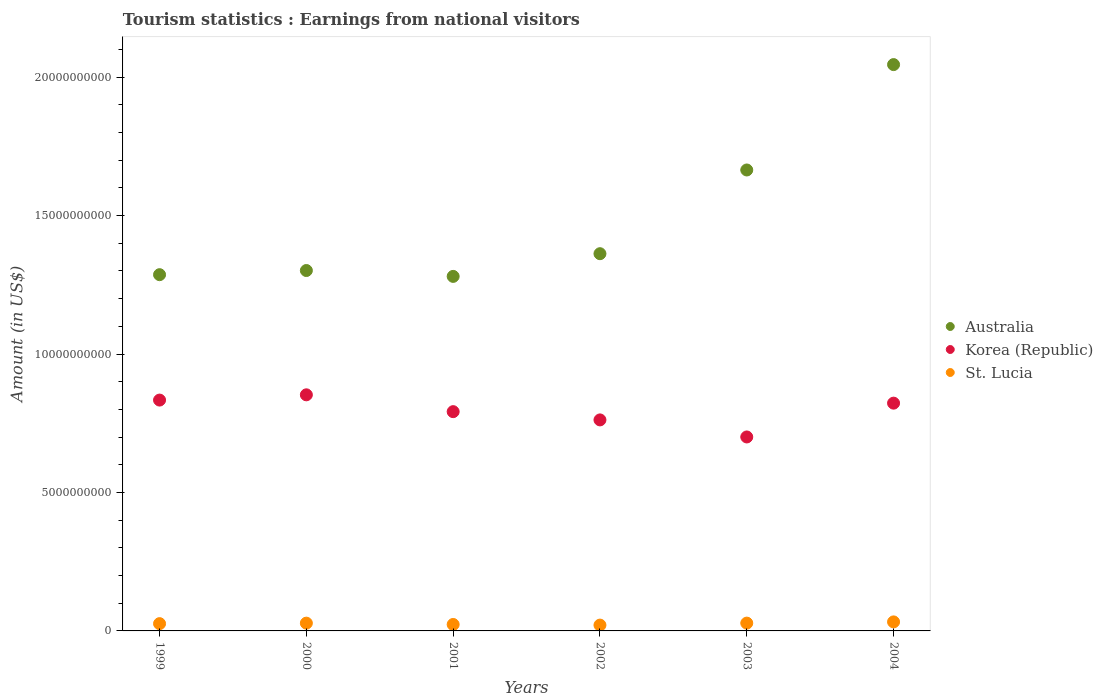How many different coloured dotlines are there?
Ensure brevity in your answer.  3. What is the earnings from national visitors in St. Lucia in 2004?
Your answer should be compact. 3.26e+08. Across all years, what is the maximum earnings from national visitors in Korea (Republic)?
Provide a short and direct response. 8.53e+09. Across all years, what is the minimum earnings from national visitors in St. Lucia?
Ensure brevity in your answer.  2.10e+08. In which year was the earnings from national visitors in Australia maximum?
Your answer should be compact. 2004. In which year was the earnings from national visitors in Korea (Republic) minimum?
Keep it short and to the point. 2003. What is the total earnings from national visitors in Australia in the graph?
Offer a very short reply. 8.94e+1. What is the difference between the earnings from national visitors in St. Lucia in 1999 and that in 2001?
Your answer should be very brief. 3.00e+07. What is the difference between the earnings from national visitors in St. Lucia in 2003 and the earnings from national visitors in Australia in 2000?
Provide a short and direct response. -1.27e+1. What is the average earnings from national visitors in St. Lucia per year?
Keep it short and to the point. 2.66e+08. In the year 2002, what is the difference between the earnings from national visitors in St. Lucia and earnings from national visitors in Korea (Republic)?
Make the answer very short. -7.41e+09. In how many years, is the earnings from national visitors in Korea (Republic) greater than 3000000000 US$?
Your answer should be very brief. 6. What is the ratio of the earnings from national visitors in St. Lucia in 2000 to that in 2003?
Ensure brevity in your answer.  1. Is the earnings from national visitors in St. Lucia in 2000 less than that in 2002?
Keep it short and to the point. No. Is the difference between the earnings from national visitors in St. Lucia in 1999 and 2004 greater than the difference between the earnings from national visitors in Korea (Republic) in 1999 and 2004?
Offer a very short reply. No. What is the difference between the highest and the second highest earnings from national visitors in Australia?
Offer a terse response. 3.81e+09. What is the difference between the highest and the lowest earnings from national visitors in Korea (Republic)?
Your answer should be very brief. 1.52e+09. Is the sum of the earnings from national visitors in Australia in 1999 and 2003 greater than the maximum earnings from national visitors in St. Lucia across all years?
Provide a succinct answer. Yes. Is the earnings from national visitors in Korea (Republic) strictly greater than the earnings from national visitors in Australia over the years?
Keep it short and to the point. No. How many dotlines are there?
Give a very brief answer. 3. How many years are there in the graph?
Your answer should be very brief. 6. Does the graph contain any zero values?
Provide a succinct answer. No. Does the graph contain grids?
Your response must be concise. No. How many legend labels are there?
Ensure brevity in your answer.  3. How are the legend labels stacked?
Provide a short and direct response. Vertical. What is the title of the graph?
Provide a short and direct response. Tourism statistics : Earnings from national visitors. Does "Sub-Saharan Africa (developing only)" appear as one of the legend labels in the graph?
Your response must be concise. No. What is the label or title of the Y-axis?
Keep it short and to the point. Amount (in US$). What is the Amount (in US$) of Australia in 1999?
Provide a short and direct response. 1.29e+1. What is the Amount (in US$) of Korea (Republic) in 1999?
Keep it short and to the point. 8.34e+09. What is the Amount (in US$) in St. Lucia in 1999?
Ensure brevity in your answer.  2.63e+08. What is the Amount (in US$) of Australia in 2000?
Your response must be concise. 1.30e+1. What is the Amount (in US$) in Korea (Republic) in 2000?
Give a very brief answer. 8.53e+09. What is the Amount (in US$) in St. Lucia in 2000?
Offer a very short reply. 2.81e+08. What is the Amount (in US$) in Australia in 2001?
Your answer should be compact. 1.28e+1. What is the Amount (in US$) of Korea (Republic) in 2001?
Offer a terse response. 7.92e+09. What is the Amount (in US$) in St. Lucia in 2001?
Keep it short and to the point. 2.33e+08. What is the Amount (in US$) in Australia in 2002?
Your answer should be very brief. 1.36e+1. What is the Amount (in US$) in Korea (Republic) in 2002?
Offer a very short reply. 7.62e+09. What is the Amount (in US$) in St. Lucia in 2002?
Keep it short and to the point. 2.10e+08. What is the Amount (in US$) in Australia in 2003?
Give a very brief answer. 1.66e+1. What is the Amount (in US$) of Korea (Republic) in 2003?
Give a very brief answer. 7.00e+09. What is the Amount (in US$) of St. Lucia in 2003?
Offer a terse response. 2.82e+08. What is the Amount (in US$) in Australia in 2004?
Keep it short and to the point. 2.05e+1. What is the Amount (in US$) in Korea (Republic) in 2004?
Provide a succinct answer. 8.23e+09. What is the Amount (in US$) of St. Lucia in 2004?
Offer a very short reply. 3.26e+08. Across all years, what is the maximum Amount (in US$) in Australia?
Ensure brevity in your answer.  2.05e+1. Across all years, what is the maximum Amount (in US$) in Korea (Republic)?
Give a very brief answer. 8.53e+09. Across all years, what is the maximum Amount (in US$) of St. Lucia?
Make the answer very short. 3.26e+08. Across all years, what is the minimum Amount (in US$) of Australia?
Offer a very short reply. 1.28e+1. Across all years, what is the minimum Amount (in US$) of Korea (Republic)?
Your answer should be very brief. 7.00e+09. Across all years, what is the minimum Amount (in US$) of St. Lucia?
Your answer should be compact. 2.10e+08. What is the total Amount (in US$) in Australia in the graph?
Provide a short and direct response. 8.94e+1. What is the total Amount (in US$) in Korea (Republic) in the graph?
Ensure brevity in your answer.  4.76e+1. What is the total Amount (in US$) in St. Lucia in the graph?
Provide a short and direct response. 1.60e+09. What is the difference between the Amount (in US$) in Australia in 1999 and that in 2000?
Keep it short and to the point. -1.50e+08. What is the difference between the Amount (in US$) of Korea (Republic) in 1999 and that in 2000?
Provide a succinct answer. -1.90e+08. What is the difference between the Amount (in US$) in St. Lucia in 1999 and that in 2000?
Offer a very short reply. -1.80e+07. What is the difference between the Amount (in US$) in Australia in 1999 and that in 2001?
Make the answer very short. 6.20e+07. What is the difference between the Amount (in US$) in Korea (Republic) in 1999 and that in 2001?
Give a very brief answer. 4.18e+08. What is the difference between the Amount (in US$) of St. Lucia in 1999 and that in 2001?
Your answer should be compact. 3.00e+07. What is the difference between the Amount (in US$) in Australia in 1999 and that in 2002?
Keep it short and to the point. -7.58e+08. What is the difference between the Amount (in US$) of Korea (Republic) in 1999 and that in 2002?
Provide a succinct answer. 7.16e+08. What is the difference between the Amount (in US$) of St. Lucia in 1999 and that in 2002?
Keep it short and to the point. 5.30e+07. What is the difference between the Amount (in US$) of Australia in 1999 and that in 2003?
Keep it short and to the point. -3.78e+09. What is the difference between the Amount (in US$) of Korea (Republic) in 1999 and that in 2003?
Keep it short and to the point. 1.33e+09. What is the difference between the Amount (in US$) of St. Lucia in 1999 and that in 2003?
Keep it short and to the point. -1.90e+07. What is the difference between the Amount (in US$) of Australia in 1999 and that in 2004?
Offer a terse response. -7.59e+09. What is the difference between the Amount (in US$) of Korea (Republic) in 1999 and that in 2004?
Your response must be concise. 1.11e+08. What is the difference between the Amount (in US$) of St. Lucia in 1999 and that in 2004?
Keep it short and to the point. -6.30e+07. What is the difference between the Amount (in US$) in Australia in 2000 and that in 2001?
Keep it short and to the point. 2.12e+08. What is the difference between the Amount (in US$) of Korea (Republic) in 2000 and that in 2001?
Ensure brevity in your answer.  6.08e+08. What is the difference between the Amount (in US$) of St. Lucia in 2000 and that in 2001?
Provide a succinct answer. 4.80e+07. What is the difference between the Amount (in US$) of Australia in 2000 and that in 2002?
Provide a short and direct response. -6.08e+08. What is the difference between the Amount (in US$) of Korea (Republic) in 2000 and that in 2002?
Your answer should be very brief. 9.06e+08. What is the difference between the Amount (in US$) in St. Lucia in 2000 and that in 2002?
Your response must be concise. 7.10e+07. What is the difference between the Amount (in US$) of Australia in 2000 and that in 2003?
Provide a short and direct response. -3.63e+09. What is the difference between the Amount (in US$) in Korea (Republic) in 2000 and that in 2003?
Provide a short and direct response. 1.52e+09. What is the difference between the Amount (in US$) of St. Lucia in 2000 and that in 2003?
Keep it short and to the point. -1.00e+06. What is the difference between the Amount (in US$) in Australia in 2000 and that in 2004?
Offer a terse response. -7.44e+09. What is the difference between the Amount (in US$) in Korea (Republic) in 2000 and that in 2004?
Offer a very short reply. 3.01e+08. What is the difference between the Amount (in US$) of St. Lucia in 2000 and that in 2004?
Keep it short and to the point. -4.50e+07. What is the difference between the Amount (in US$) of Australia in 2001 and that in 2002?
Offer a terse response. -8.20e+08. What is the difference between the Amount (in US$) of Korea (Republic) in 2001 and that in 2002?
Your answer should be very brief. 2.98e+08. What is the difference between the Amount (in US$) of St. Lucia in 2001 and that in 2002?
Ensure brevity in your answer.  2.30e+07. What is the difference between the Amount (in US$) of Australia in 2001 and that in 2003?
Give a very brief answer. -3.84e+09. What is the difference between the Amount (in US$) in Korea (Republic) in 2001 and that in 2003?
Ensure brevity in your answer.  9.14e+08. What is the difference between the Amount (in US$) of St. Lucia in 2001 and that in 2003?
Offer a very short reply. -4.90e+07. What is the difference between the Amount (in US$) in Australia in 2001 and that in 2004?
Offer a very short reply. -7.65e+09. What is the difference between the Amount (in US$) of Korea (Republic) in 2001 and that in 2004?
Your answer should be very brief. -3.07e+08. What is the difference between the Amount (in US$) of St. Lucia in 2001 and that in 2004?
Offer a terse response. -9.30e+07. What is the difference between the Amount (in US$) in Australia in 2002 and that in 2003?
Your answer should be very brief. -3.02e+09. What is the difference between the Amount (in US$) in Korea (Republic) in 2002 and that in 2003?
Offer a terse response. 6.16e+08. What is the difference between the Amount (in US$) of St. Lucia in 2002 and that in 2003?
Your answer should be compact. -7.20e+07. What is the difference between the Amount (in US$) of Australia in 2002 and that in 2004?
Your response must be concise. -6.83e+09. What is the difference between the Amount (in US$) in Korea (Republic) in 2002 and that in 2004?
Ensure brevity in your answer.  -6.05e+08. What is the difference between the Amount (in US$) of St. Lucia in 2002 and that in 2004?
Your answer should be compact. -1.16e+08. What is the difference between the Amount (in US$) of Australia in 2003 and that in 2004?
Keep it short and to the point. -3.81e+09. What is the difference between the Amount (in US$) in Korea (Republic) in 2003 and that in 2004?
Your answer should be very brief. -1.22e+09. What is the difference between the Amount (in US$) in St. Lucia in 2003 and that in 2004?
Offer a very short reply. -4.40e+07. What is the difference between the Amount (in US$) in Australia in 1999 and the Amount (in US$) in Korea (Republic) in 2000?
Offer a very short reply. 4.34e+09. What is the difference between the Amount (in US$) in Australia in 1999 and the Amount (in US$) in St. Lucia in 2000?
Your answer should be compact. 1.26e+1. What is the difference between the Amount (in US$) in Korea (Republic) in 1999 and the Amount (in US$) in St. Lucia in 2000?
Your answer should be compact. 8.06e+09. What is the difference between the Amount (in US$) in Australia in 1999 and the Amount (in US$) in Korea (Republic) in 2001?
Offer a very short reply. 4.95e+09. What is the difference between the Amount (in US$) in Australia in 1999 and the Amount (in US$) in St. Lucia in 2001?
Provide a short and direct response. 1.26e+1. What is the difference between the Amount (in US$) in Korea (Republic) in 1999 and the Amount (in US$) in St. Lucia in 2001?
Provide a succinct answer. 8.10e+09. What is the difference between the Amount (in US$) in Australia in 1999 and the Amount (in US$) in Korea (Republic) in 2002?
Offer a very short reply. 5.24e+09. What is the difference between the Amount (in US$) of Australia in 1999 and the Amount (in US$) of St. Lucia in 2002?
Ensure brevity in your answer.  1.27e+1. What is the difference between the Amount (in US$) of Korea (Republic) in 1999 and the Amount (in US$) of St. Lucia in 2002?
Provide a succinct answer. 8.13e+09. What is the difference between the Amount (in US$) in Australia in 1999 and the Amount (in US$) in Korea (Republic) in 2003?
Make the answer very short. 5.86e+09. What is the difference between the Amount (in US$) of Australia in 1999 and the Amount (in US$) of St. Lucia in 2003?
Your answer should be compact. 1.26e+1. What is the difference between the Amount (in US$) of Korea (Republic) in 1999 and the Amount (in US$) of St. Lucia in 2003?
Your response must be concise. 8.06e+09. What is the difference between the Amount (in US$) in Australia in 1999 and the Amount (in US$) in Korea (Republic) in 2004?
Offer a very short reply. 4.64e+09. What is the difference between the Amount (in US$) in Australia in 1999 and the Amount (in US$) in St. Lucia in 2004?
Provide a succinct answer. 1.25e+1. What is the difference between the Amount (in US$) in Korea (Republic) in 1999 and the Amount (in US$) in St. Lucia in 2004?
Provide a succinct answer. 8.01e+09. What is the difference between the Amount (in US$) in Australia in 2000 and the Amount (in US$) in Korea (Republic) in 2001?
Your response must be concise. 5.10e+09. What is the difference between the Amount (in US$) in Australia in 2000 and the Amount (in US$) in St. Lucia in 2001?
Give a very brief answer. 1.28e+1. What is the difference between the Amount (in US$) in Korea (Republic) in 2000 and the Amount (in US$) in St. Lucia in 2001?
Your answer should be compact. 8.29e+09. What is the difference between the Amount (in US$) of Australia in 2000 and the Amount (in US$) of Korea (Republic) in 2002?
Offer a very short reply. 5.40e+09. What is the difference between the Amount (in US$) of Australia in 2000 and the Amount (in US$) of St. Lucia in 2002?
Provide a short and direct response. 1.28e+1. What is the difference between the Amount (in US$) of Korea (Republic) in 2000 and the Amount (in US$) of St. Lucia in 2002?
Keep it short and to the point. 8.32e+09. What is the difference between the Amount (in US$) of Australia in 2000 and the Amount (in US$) of Korea (Republic) in 2003?
Keep it short and to the point. 6.01e+09. What is the difference between the Amount (in US$) in Australia in 2000 and the Amount (in US$) in St. Lucia in 2003?
Your answer should be compact. 1.27e+1. What is the difference between the Amount (in US$) in Korea (Republic) in 2000 and the Amount (in US$) in St. Lucia in 2003?
Offer a very short reply. 8.24e+09. What is the difference between the Amount (in US$) of Australia in 2000 and the Amount (in US$) of Korea (Republic) in 2004?
Ensure brevity in your answer.  4.79e+09. What is the difference between the Amount (in US$) of Australia in 2000 and the Amount (in US$) of St. Lucia in 2004?
Your answer should be very brief. 1.27e+1. What is the difference between the Amount (in US$) of Korea (Republic) in 2000 and the Amount (in US$) of St. Lucia in 2004?
Provide a succinct answer. 8.20e+09. What is the difference between the Amount (in US$) in Australia in 2001 and the Amount (in US$) in Korea (Republic) in 2002?
Make the answer very short. 5.18e+09. What is the difference between the Amount (in US$) of Australia in 2001 and the Amount (in US$) of St. Lucia in 2002?
Provide a succinct answer. 1.26e+1. What is the difference between the Amount (in US$) in Korea (Republic) in 2001 and the Amount (in US$) in St. Lucia in 2002?
Offer a terse response. 7.71e+09. What is the difference between the Amount (in US$) in Australia in 2001 and the Amount (in US$) in Korea (Republic) in 2003?
Offer a terse response. 5.80e+09. What is the difference between the Amount (in US$) of Australia in 2001 and the Amount (in US$) of St. Lucia in 2003?
Make the answer very short. 1.25e+1. What is the difference between the Amount (in US$) of Korea (Republic) in 2001 and the Amount (in US$) of St. Lucia in 2003?
Offer a terse response. 7.64e+09. What is the difference between the Amount (in US$) in Australia in 2001 and the Amount (in US$) in Korea (Republic) in 2004?
Your answer should be very brief. 4.58e+09. What is the difference between the Amount (in US$) of Australia in 2001 and the Amount (in US$) of St. Lucia in 2004?
Your answer should be very brief. 1.25e+1. What is the difference between the Amount (in US$) in Korea (Republic) in 2001 and the Amount (in US$) in St. Lucia in 2004?
Provide a short and direct response. 7.59e+09. What is the difference between the Amount (in US$) in Australia in 2002 and the Amount (in US$) in Korea (Republic) in 2003?
Make the answer very short. 6.62e+09. What is the difference between the Amount (in US$) of Australia in 2002 and the Amount (in US$) of St. Lucia in 2003?
Keep it short and to the point. 1.33e+1. What is the difference between the Amount (in US$) of Korea (Republic) in 2002 and the Amount (in US$) of St. Lucia in 2003?
Ensure brevity in your answer.  7.34e+09. What is the difference between the Amount (in US$) of Australia in 2002 and the Amount (in US$) of Korea (Republic) in 2004?
Offer a very short reply. 5.40e+09. What is the difference between the Amount (in US$) of Australia in 2002 and the Amount (in US$) of St. Lucia in 2004?
Offer a terse response. 1.33e+1. What is the difference between the Amount (in US$) of Korea (Republic) in 2002 and the Amount (in US$) of St. Lucia in 2004?
Keep it short and to the point. 7.30e+09. What is the difference between the Amount (in US$) in Australia in 2003 and the Amount (in US$) in Korea (Republic) in 2004?
Your response must be concise. 8.42e+09. What is the difference between the Amount (in US$) in Australia in 2003 and the Amount (in US$) in St. Lucia in 2004?
Your answer should be compact. 1.63e+1. What is the difference between the Amount (in US$) of Korea (Republic) in 2003 and the Amount (in US$) of St. Lucia in 2004?
Offer a terse response. 6.68e+09. What is the average Amount (in US$) of Australia per year?
Provide a succinct answer. 1.49e+1. What is the average Amount (in US$) in Korea (Republic) per year?
Provide a short and direct response. 7.94e+09. What is the average Amount (in US$) in St. Lucia per year?
Your response must be concise. 2.66e+08. In the year 1999, what is the difference between the Amount (in US$) of Australia and Amount (in US$) of Korea (Republic)?
Provide a short and direct response. 4.53e+09. In the year 1999, what is the difference between the Amount (in US$) of Australia and Amount (in US$) of St. Lucia?
Your answer should be very brief. 1.26e+1. In the year 1999, what is the difference between the Amount (in US$) in Korea (Republic) and Amount (in US$) in St. Lucia?
Give a very brief answer. 8.07e+09. In the year 2000, what is the difference between the Amount (in US$) of Australia and Amount (in US$) of Korea (Republic)?
Make the answer very short. 4.49e+09. In the year 2000, what is the difference between the Amount (in US$) of Australia and Amount (in US$) of St. Lucia?
Ensure brevity in your answer.  1.27e+1. In the year 2000, what is the difference between the Amount (in US$) in Korea (Republic) and Amount (in US$) in St. Lucia?
Keep it short and to the point. 8.25e+09. In the year 2001, what is the difference between the Amount (in US$) in Australia and Amount (in US$) in Korea (Republic)?
Make the answer very short. 4.88e+09. In the year 2001, what is the difference between the Amount (in US$) of Australia and Amount (in US$) of St. Lucia?
Your answer should be compact. 1.26e+1. In the year 2001, what is the difference between the Amount (in US$) in Korea (Republic) and Amount (in US$) in St. Lucia?
Keep it short and to the point. 7.69e+09. In the year 2002, what is the difference between the Amount (in US$) of Australia and Amount (in US$) of Korea (Republic)?
Offer a very short reply. 6.00e+09. In the year 2002, what is the difference between the Amount (in US$) in Australia and Amount (in US$) in St. Lucia?
Provide a succinct answer. 1.34e+1. In the year 2002, what is the difference between the Amount (in US$) of Korea (Republic) and Amount (in US$) of St. Lucia?
Offer a very short reply. 7.41e+09. In the year 2003, what is the difference between the Amount (in US$) in Australia and Amount (in US$) in Korea (Republic)?
Give a very brief answer. 9.64e+09. In the year 2003, what is the difference between the Amount (in US$) in Australia and Amount (in US$) in St. Lucia?
Ensure brevity in your answer.  1.64e+1. In the year 2003, what is the difference between the Amount (in US$) of Korea (Republic) and Amount (in US$) of St. Lucia?
Offer a very short reply. 6.72e+09. In the year 2004, what is the difference between the Amount (in US$) of Australia and Amount (in US$) of Korea (Republic)?
Give a very brief answer. 1.22e+1. In the year 2004, what is the difference between the Amount (in US$) of Australia and Amount (in US$) of St. Lucia?
Your answer should be very brief. 2.01e+1. In the year 2004, what is the difference between the Amount (in US$) in Korea (Republic) and Amount (in US$) in St. Lucia?
Provide a succinct answer. 7.90e+09. What is the ratio of the Amount (in US$) of Australia in 1999 to that in 2000?
Offer a terse response. 0.99. What is the ratio of the Amount (in US$) in Korea (Republic) in 1999 to that in 2000?
Keep it short and to the point. 0.98. What is the ratio of the Amount (in US$) in St. Lucia in 1999 to that in 2000?
Your response must be concise. 0.94. What is the ratio of the Amount (in US$) of Korea (Republic) in 1999 to that in 2001?
Offer a very short reply. 1.05. What is the ratio of the Amount (in US$) of St. Lucia in 1999 to that in 2001?
Give a very brief answer. 1.13. What is the ratio of the Amount (in US$) of Australia in 1999 to that in 2002?
Your response must be concise. 0.94. What is the ratio of the Amount (in US$) in Korea (Republic) in 1999 to that in 2002?
Your answer should be very brief. 1.09. What is the ratio of the Amount (in US$) in St. Lucia in 1999 to that in 2002?
Provide a succinct answer. 1.25. What is the ratio of the Amount (in US$) in Australia in 1999 to that in 2003?
Provide a succinct answer. 0.77. What is the ratio of the Amount (in US$) of Korea (Republic) in 1999 to that in 2003?
Your answer should be compact. 1.19. What is the ratio of the Amount (in US$) of St. Lucia in 1999 to that in 2003?
Give a very brief answer. 0.93. What is the ratio of the Amount (in US$) in Australia in 1999 to that in 2004?
Provide a short and direct response. 0.63. What is the ratio of the Amount (in US$) in Korea (Republic) in 1999 to that in 2004?
Give a very brief answer. 1.01. What is the ratio of the Amount (in US$) of St. Lucia in 1999 to that in 2004?
Ensure brevity in your answer.  0.81. What is the ratio of the Amount (in US$) of Australia in 2000 to that in 2001?
Your response must be concise. 1.02. What is the ratio of the Amount (in US$) of Korea (Republic) in 2000 to that in 2001?
Offer a terse response. 1.08. What is the ratio of the Amount (in US$) of St. Lucia in 2000 to that in 2001?
Make the answer very short. 1.21. What is the ratio of the Amount (in US$) of Australia in 2000 to that in 2002?
Give a very brief answer. 0.96. What is the ratio of the Amount (in US$) of Korea (Republic) in 2000 to that in 2002?
Give a very brief answer. 1.12. What is the ratio of the Amount (in US$) in St. Lucia in 2000 to that in 2002?
Provide a short and direct response. 1.34. What is the ratio of the Amount (in US$) in Australia in 2000 to that in 2003?
Give a very brief answer. 0.78. What is the ratio of the Amount (in US$) in Korea (Republic) in 2000 to that in 2003?
Ensure brevity in your answer.  1.22. What is the ratio of the Amount (in US$) in St. Lucia in 2000 to that in 2003?
Ensure brevity in your answer.  1. What is the ratio of the Amount (in US$) of Australia in 2000 to that in 2004?
Provide a succinct answer. 0.64. What is the ratio of the Amount (in US$) of Korea (Republic) in 2000 to that in 2004?
Make the answer very short. 1.04. What is the ratio of the Amount (in US$) in St. Lucia in 2000 to that in 2004?
Provide a short and direct response. 0.86. What is the ratio of the Amount (in US$) in Australia in 2001 to that in 2002?
Your answer should be very brief. 0.94. What is the ratio of the Amount (in US$) in Korea (Republic) in 2001 to that in 2002?
Provide a succinct answer. 1.04. What is the ratio of the Amount (in US$) in St. Lucia in 2001 to that in 2002?
Your answer should be compact. 1.11. What is the ratio of the Amount (in US$) in Australia in 2001 to that in 2003?
Ensure brevity in your answer.  0.77. What is the ratio of the Amount (in US$) in Korea (Republic) in 2001 to that in 2003?
Provide a short and direct response. 1.13. What is the ratio of the Amount (in US$) of St. Lucia in 2001 to that in 2003?
Ensure brevity in your answer.  0.83. What is the ratio of the Amount (in US$) of Australia in 2001 to that in 2004?
Ensure brevity in your answer.  0.63. What is the ratio of the Amount (in US$) in Korea (Republic) in 2001 to that in 2004?
Provide a succinct answer. 0.96. What is the ratio of the Amount (in US$) in St. Lucia in 2001 to that in 2004?
Ensure brevity in your answer.  0.71. What is the ratio of the Amount (in US$) in Australia in 2002 to that in 2003?
Ensure brevity in your answer.  0.82. What is the ratio of the Amount (in US$) in Korea (Republic) in 2002 to that in 2003?
Your response must be concise. 1.09. What is the ratio of the Amount (in US$) in St. Lucia in 2002 to that in 2003?
Ensure brevity in your answer.  0.74. What is the ratio of the Amount (in US$) of Australia in 2002 to that in 2004?
Ensure brevity in your answer.  0.67. What is the ratio of the Amount (in US$) of Korea (Republic) in 2002 to that in 2004?
Ensure brevity in your answer.  0.93. What is the ratio of the Amount (in US$) in St. Lucia in 2002 to that in 2004?
Make the answer very short. 0.64. What is the ratio of the Amount (in US$) in Australia in 2003 to that in 2004?
Offer a terse response. 0.81. What is the ratio of the Amount (in US$) of Korea (Republic) in 2003 to that in 2004?
Your answer should be compact. 0.85. What is the ratio of the Amount (in US$) of St. Lucia in 2003 to that in 2004?
Offer a terse response. 0.86. What is the difference between the highest and the second highest Amount (in US$) of Australia?
Your response must be concise. 3.81e+09. What is the difference between the highest and the second highest Amount (in US$) in Korea (Republic)?
Your answer should be compact. 1.90e+08. What is the difference between the highest and the second highest Amount (in US$) of St. Lucia?
Make the answer very short. 4.40e+07. What is the difference between the highest and the lowest Amount (in US$) of Australia?
Your answer should be compact. 7.65e+09. What is the difference between the highest and the lowest Amount (in US$) in Korea (Republic)?
Ensure brevity in your answer.  1.52e+09. What is the difference between the highest and the lowest Amount (in US$) of St. Lucia?
Offer a very short reply. 1.16e+08. 